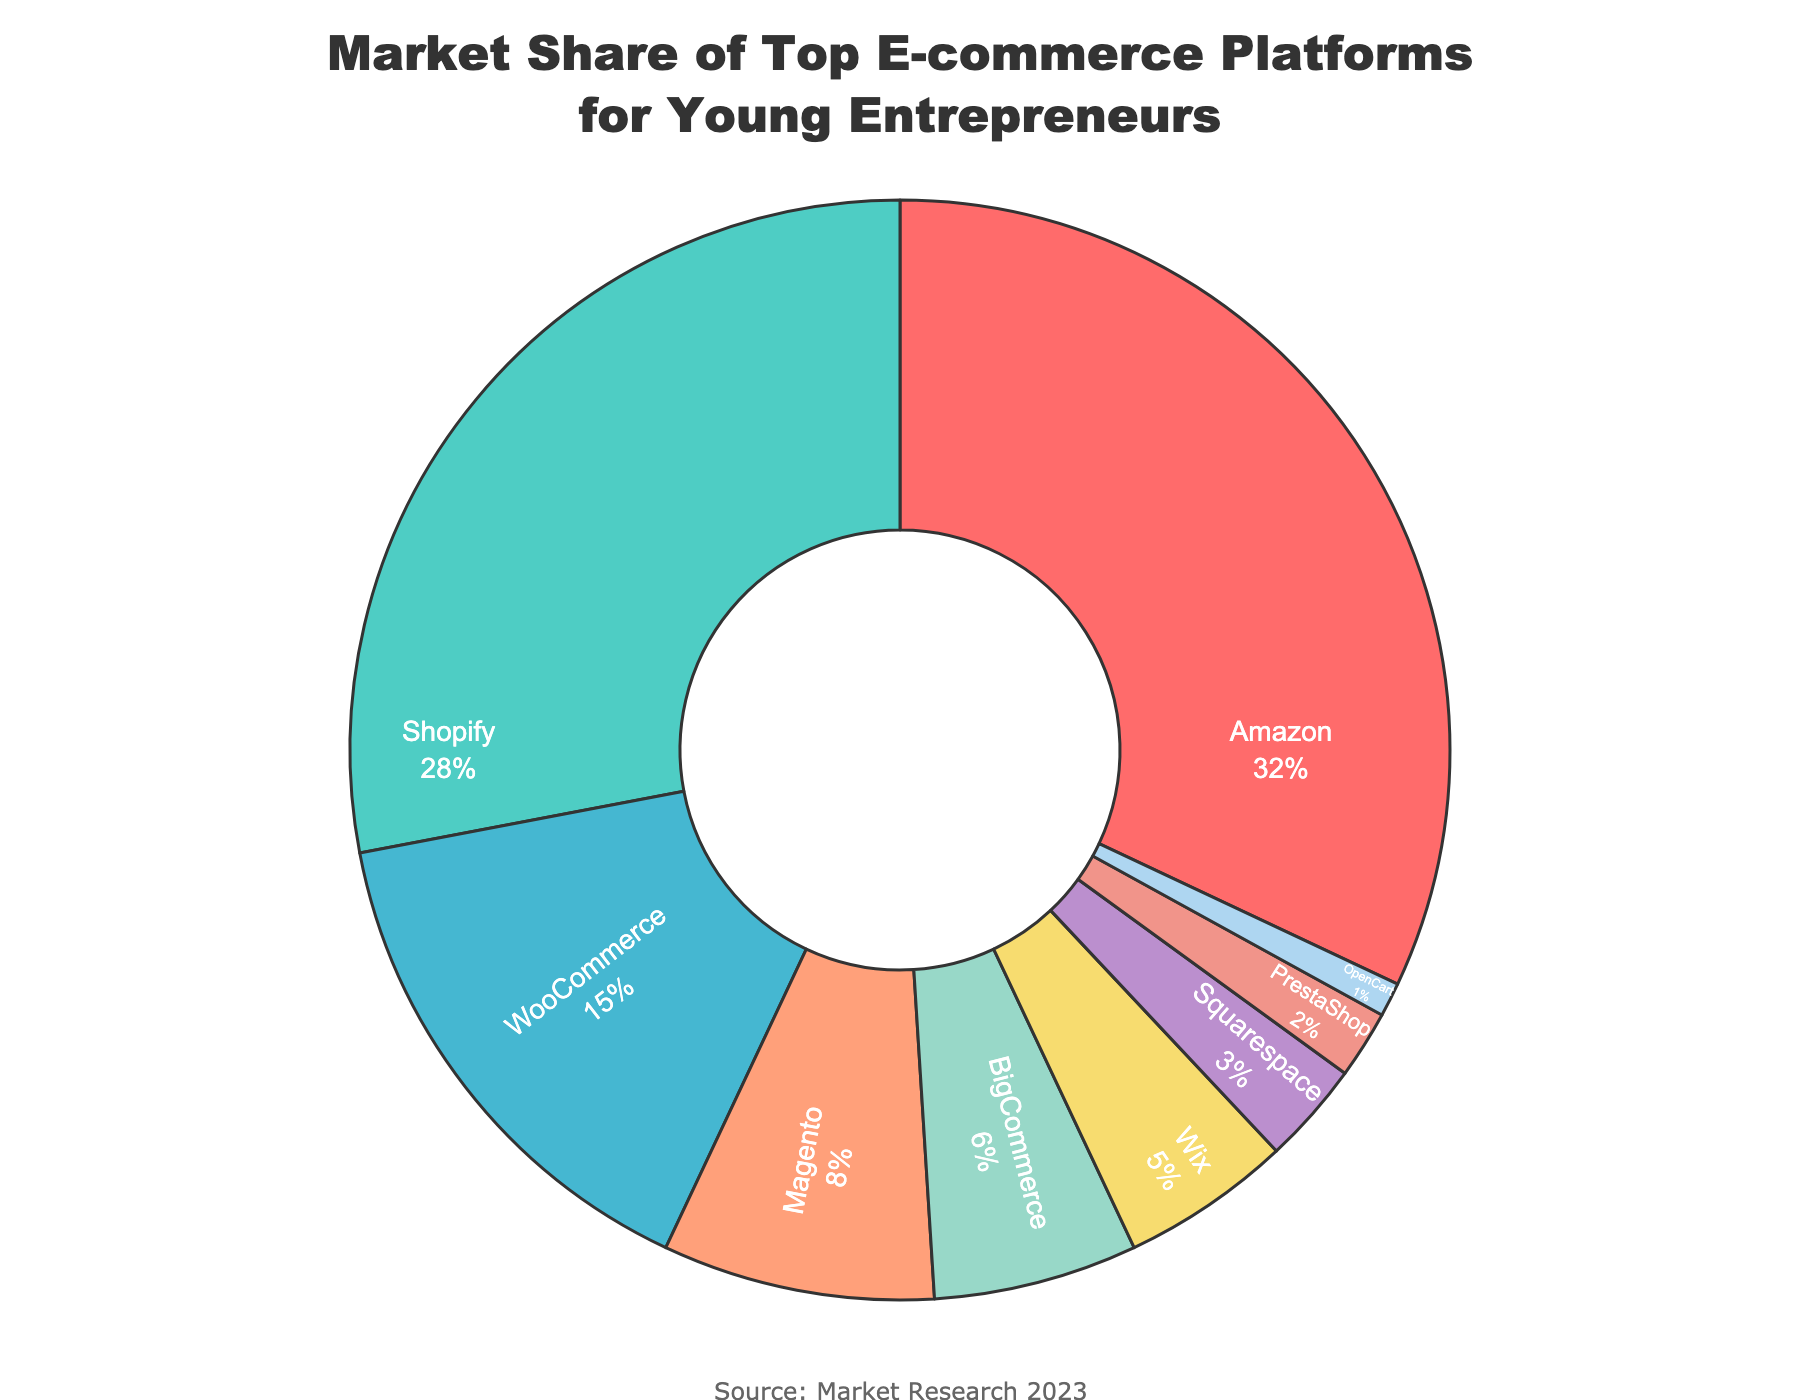Which e-commerce platform holds the largest market share among young entrepreneurs? The pie chart shows that Amazon has the largest market share with 32%.
Answer: Amazon How much more market share does Shopify have compared to WooCommerce? Shopify has a market share of 28%, while WooCommerce has 15%. The difference is 28% - 15% = 13%.
Answer: 13% What is the combined market share of BigCommerce and Wix? BigCommerce has a market share of 6% and Wix has 5%. The combined market share is 6% + 5% = 11%.
Answer: 11% Which two platforms have the smallest market shares, and what are their combined market shares? OpenCart has a 1% market share, and PrestaShop has 2%. Their combined market share is 1% + 2% = 3%.
Answer: OpenCart and PrestaShop, 3% Looking at the colors in the pie chart, which platform is represented by a red section? The pie chart has a custom color palette, and Amazon is represented by the red section.
Answer: Amazon Which platforms hold a market share greater than 20%? Based on the pie chart, Amazon (32%) and Shopify (28%) hold market shares greater than 20%.
Answer: Amazon and Shopify Calculate the percentage of the market that the top three platforms hold together? The top three platforms are Amazon (32%), Shopify (28%), and WooCommerce (15%). Their combined share is 32% + 28% + 15% = 75%.
Answer: 75% By how much does the market share of Magento differ from that of Shopify? Magento has a market share of 8%, while Shopify has 28%. The difference is 28% - 8% = 20%.
Answer: 20% What is the median market share among all the platforms listed? The market shares in ascending order are: 1%, 2%, 3%, 5%, 6%, 8%, 15%, 28%, 32%. The median value is the middle one, which is 6%.
Answer: 6% How much of the market share is held by platforms that each have less than 10%? Platforms with less than 10% are Magento (8%), BigCommerce (6%), Wix (5%), Squarespace (3%), PrestaShop (2%), OpenCart (1%). Their combined share is 8% + 6% + 5% + 3% + 2% + 1% = 25%.
Answer: 25% 